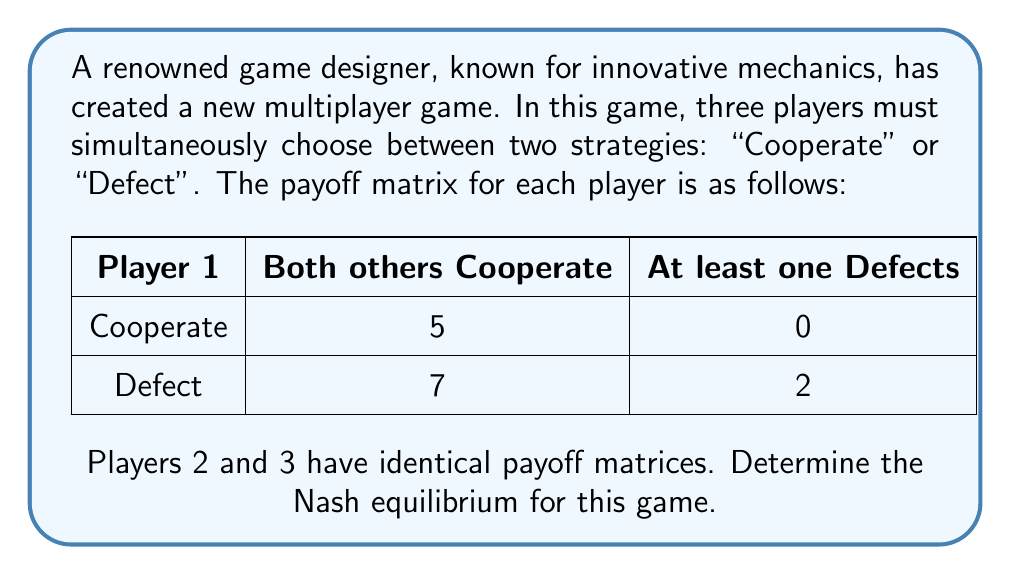Help me with this question. To find the Nash equilibrium, we need to analyze each player's best response to the other players' strategies.

1) First, let's consider Player 1's perspective:
   - If both others cooperate, Player 1 gets 5 for cooperating and 7 for defecting.
   - If at least one other defects, Player 1 gets 0 for cooperating and 2 for defecting.
   In both cases, defecting yields a higher payoff for Player 1.

2) The same logic applies to Players 2 and 3, as they have identical payoff matrices.

3) Therefore, regardless of what the other players do, each player's best strategy is to defect.

4) When all players defect, no player can unilaterally improve their payoff by changing their strategy.

5) This situation, where all players defect, satisfies the definition of a Nash equilibrium:
   $$(D, D, D)$$
   where $D$ represents the "Defect" strategy for each player.

6) We can verify this:
   - If any player unilaterally switches to "Cooperate", their payoff would decrease from 2 to 0.
   - Thus, no player has an incentive to deviate from the (D, D, D) strategy profile.

7) Note that this game exhibits a "Tragedy of the Commons" scenario, where individual rational behavior leads to a suboptimal outcome for all players. If all players cooperated, they would each receive a payoff of 5, which is higher than the equilibrium payoff of 2.
Answer: The Nash equilibrium for this game is $$(D, D, D)$$, where all three players choose the "Defect" strategy. 